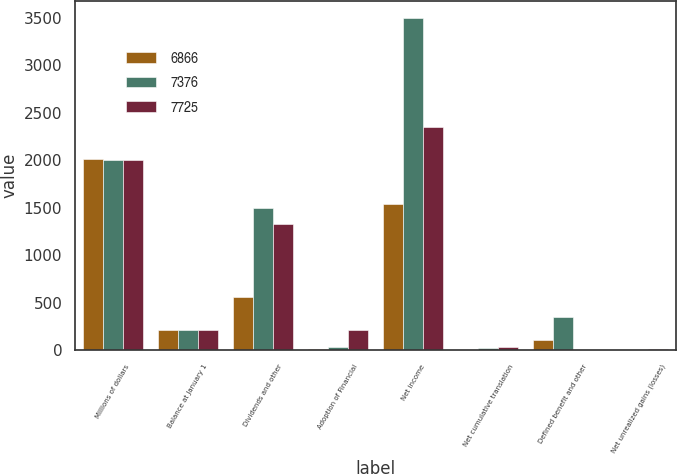<chart> <loc_0><loc_0><loc_500><loc_500><stacked_bar_chart><ecel><fcel>Millions of dollars<fcel>Balance at January 1<fcel>Dividends and other<fcel>Adoption of Financial<fcel>Net income<fcel>Net cumulative translation<fcel>Defined benefit and other<fcel>Net unrealized gains (losses)<nl><fcel>6866<fcel>2008<fcel>218<fcel>558<fcel>10<fcel>1538<fcel>1<fcel>106<fcel>6<nl><fcel>7376<fcel>2007<fcel>218<fcel>1499<fcel>30<fcel>3499<fcel>23<fcel>355<fcel>1<nl><fcel>7725<fcel>2006<fcel>218<fcel>1324<fcel>218<fcel>2348<fcel>34<fcel>2<fcel>11<nl></chart> 